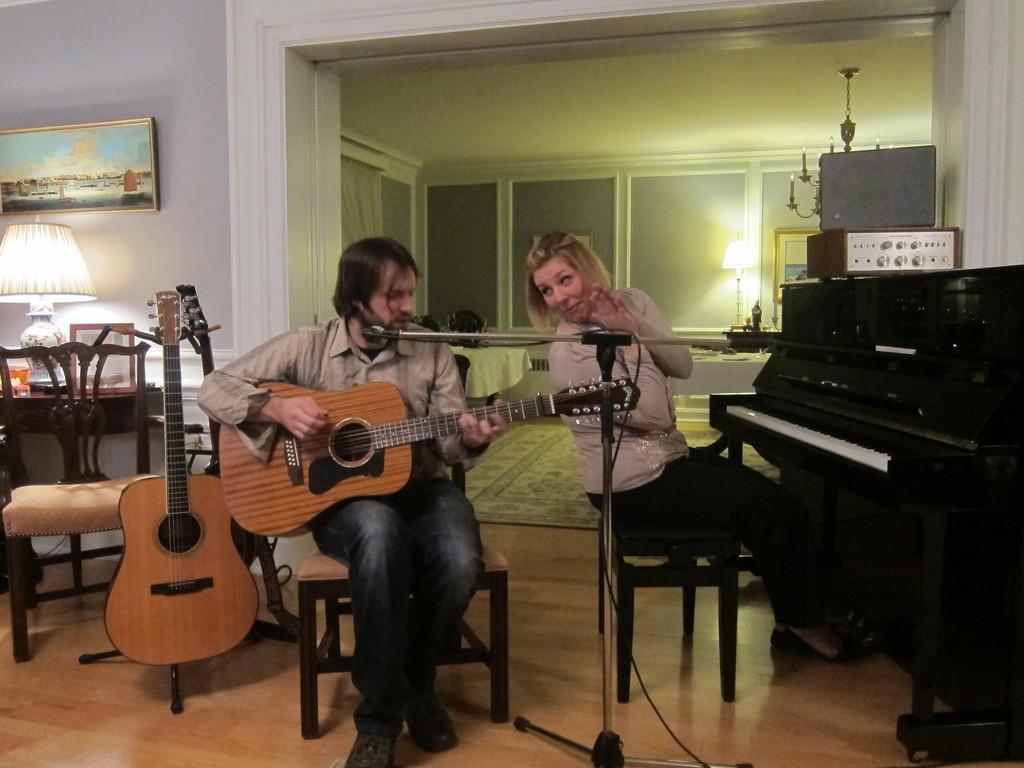How would you summarize this image in a sentence or two? In this picture we can see a man and a woman sitting on the chairs. He is playing guitar. And this is piano. And there is a frame on the wall. This is lamp. On the background there is a wall. 